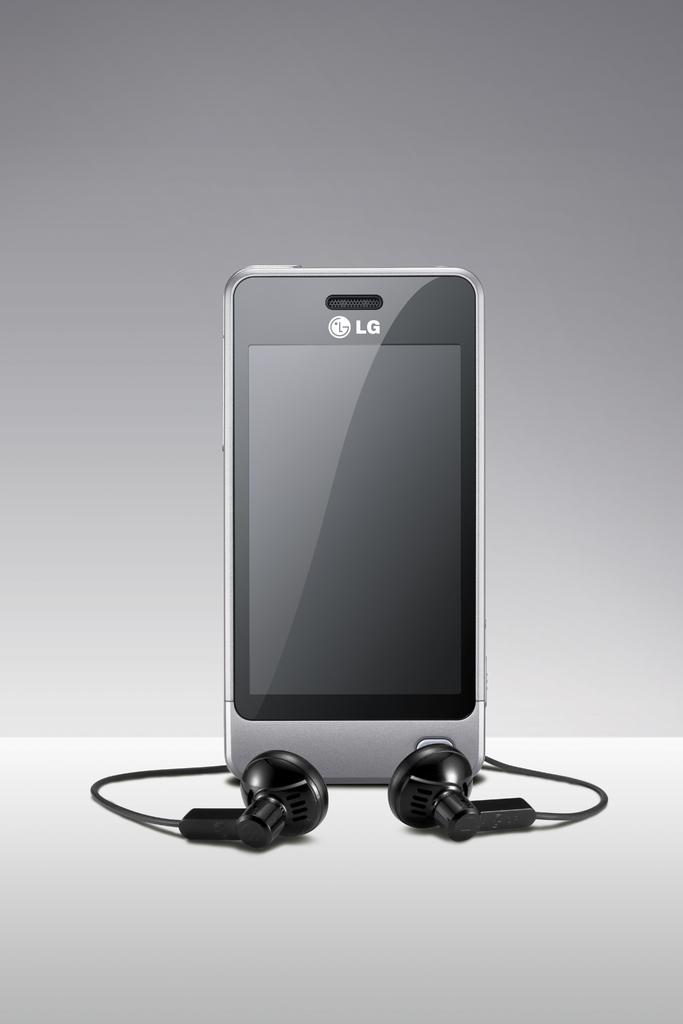<image>
Write a terse but informative summary of the picture. A phone with headphones has the letters LG on the front. 